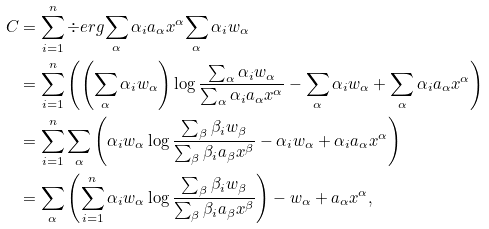<formula> <loc_0><loc_0><loc_500><loc_500>C & = \sum _ { i = 1 } ^ { n } \div e r g { \sum _ { \alpha } \alpha _ { i } a _ { \alpha } x ^ { \alpha } } { \sum _ { \alpha } \alpha _ { i } w _ { \alpha } } \\ & = \sum _ { i = 1 } ^ { n } \left ( \left ( \sum _ { \alpha } \alpha _ { i } w _ { \alpha } \right ) \log \frac { \sum _ { \alpha } \alpha _ { i } w _ { \alpha } } { \sum _ { \alpha } \alpha _ { i } a _ { \alpha } x ^ { \alpha } } - \sum _ { \alpha } \alpha _ { i } w _ { \alpha } + \sum _ { \alpha } \alpha _ { i } a _ { \alpha } x ^ { \alpha } \right ) \\ & = \sum _ { i = 1 } ^ { n } \sum _ { \alpha } \left ( \alpha _ { i } w _ { \alpha } \log \frac { \sum _ { \beta } \beta _ { i } w _ { \beta } } { \sum _ { \beta } \beta _ { i } a _ { \beta } x ^ { \beta } } - \alpha _ { i } w _ { \alpha } + \alpha _ { i } a _ { \alpha } x ^ { \alpha } \right ) \\ & = \sum _ { \alpha } \left ( \sum _ { i = 1 } ^ { n } \alpha _ { i } w _ { \alpha } \log \frac { \sum _ { \beta } \beta _ { i } w _ { \beta } } { \sum _ { \beta } \beta _ { i } a _ { \beta } x ^ { \beta } } \right ) - w _ { \alpha } + a _ { \alpha } x ^ { \alpha } ,</formula> 